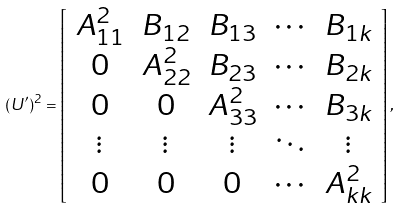Convert formula to latex. <formula><loc_0><loc_0><loc_500><loc_500>( U ^ { \prime } ) ^ { 2 } = \left [ \begin{array} { c c c c c } A _ { 1 1 } ^ { 2 } & B _ { 1 2 } & B _ { 1 3 } & \cdots & B _ { 1 k } \\ 0 & A _ { 2 2 } ^ { 2 } & B _ { 2 3 } & \cdots & B _ { 2 k } \\ 0 & 0 & A _ { 3 3 } ^ { 2 } & \cdots & B _ { 3 k } \\ \vdots & \vdots & \vdots & \ddots & \vdots \\ 0 & 0 & 0 & \cdots & A _ { k k } ^ { 2 } \end{array} \right ] ,</formula> 